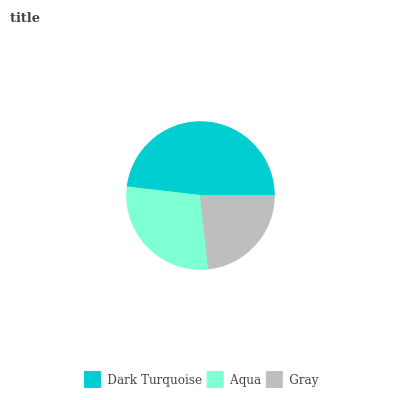Is Gray the minimum?
Answer yes or no. Yes. Is Dark Turquoise the maximum?
Answer yes or no. Yes. Is Aqua the minimum?
Answer yes or no. No. Is Aqua the maximum?
Answer yes or no. No. Is Dark Turquoise greater than Aqua?
Answer yes or no. Yes. Is Aqua less than Dark Turquoise?
Answer yes or no. Yes. Is Aqua greater than Dark Turquoise?
Answer yes or no. No. Is Dark Turquoise less than Aqua?
Answer yes or no. No. Is Aqua the high median?
Answer yes or no. Yes. Is Aqua the low median?
Answer yes or no. Yes. Is Dark Turquoise the high median?
Answer yes or no. No. Is Dark Turquoise the low median?
Answer yes or no. No. 